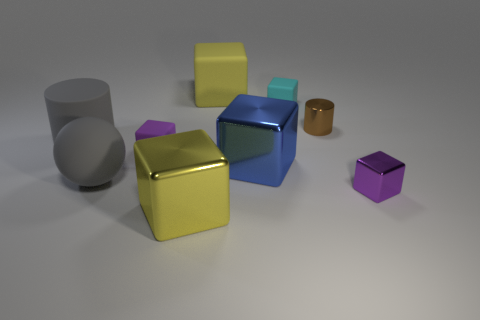Subtract all large blue metal blocks. How many blocks are left? 5 Add 1 big matte balls. How many objects exist? 10 Subtract all purple cubes. How many cubes are left? 4 Subtract 1 cylinders. How many cylinders are left? 1 Subtract all cyan rubber blocks. Subtract all large balls. How many objects are left? 7 Add 5 brown shiny cylinders. How many brown shiny cylinders are left? 6 Add 4 large red things. How many large red things exist? 4 Subtract 1 cyan blocks. How many objects are left? 8 Subtract all spheres. How many objects are left? 8 Subtract all red cylinders. Subtract all green balls. How many cylinders are left? 2 